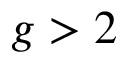<formula> <loc_0><loc_0><loc_500><loc_500>g > 2</formula> 